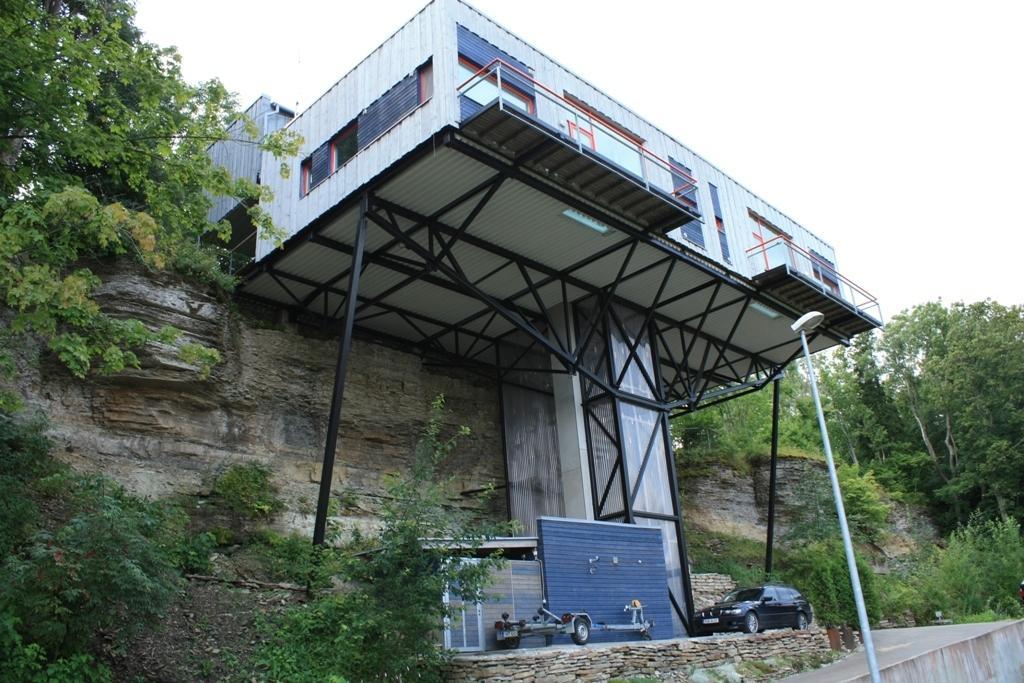In one or two sentences, can you explain what this image depicts? This picture is clicked outside. In the foreground we can see the plants and trees and we can see a light attached to the pole. In the center we can see a black color car and some objects placed on the ground and we can see the metal rods and some metal objects. In the background we can see the sky, trees and many other objects. 